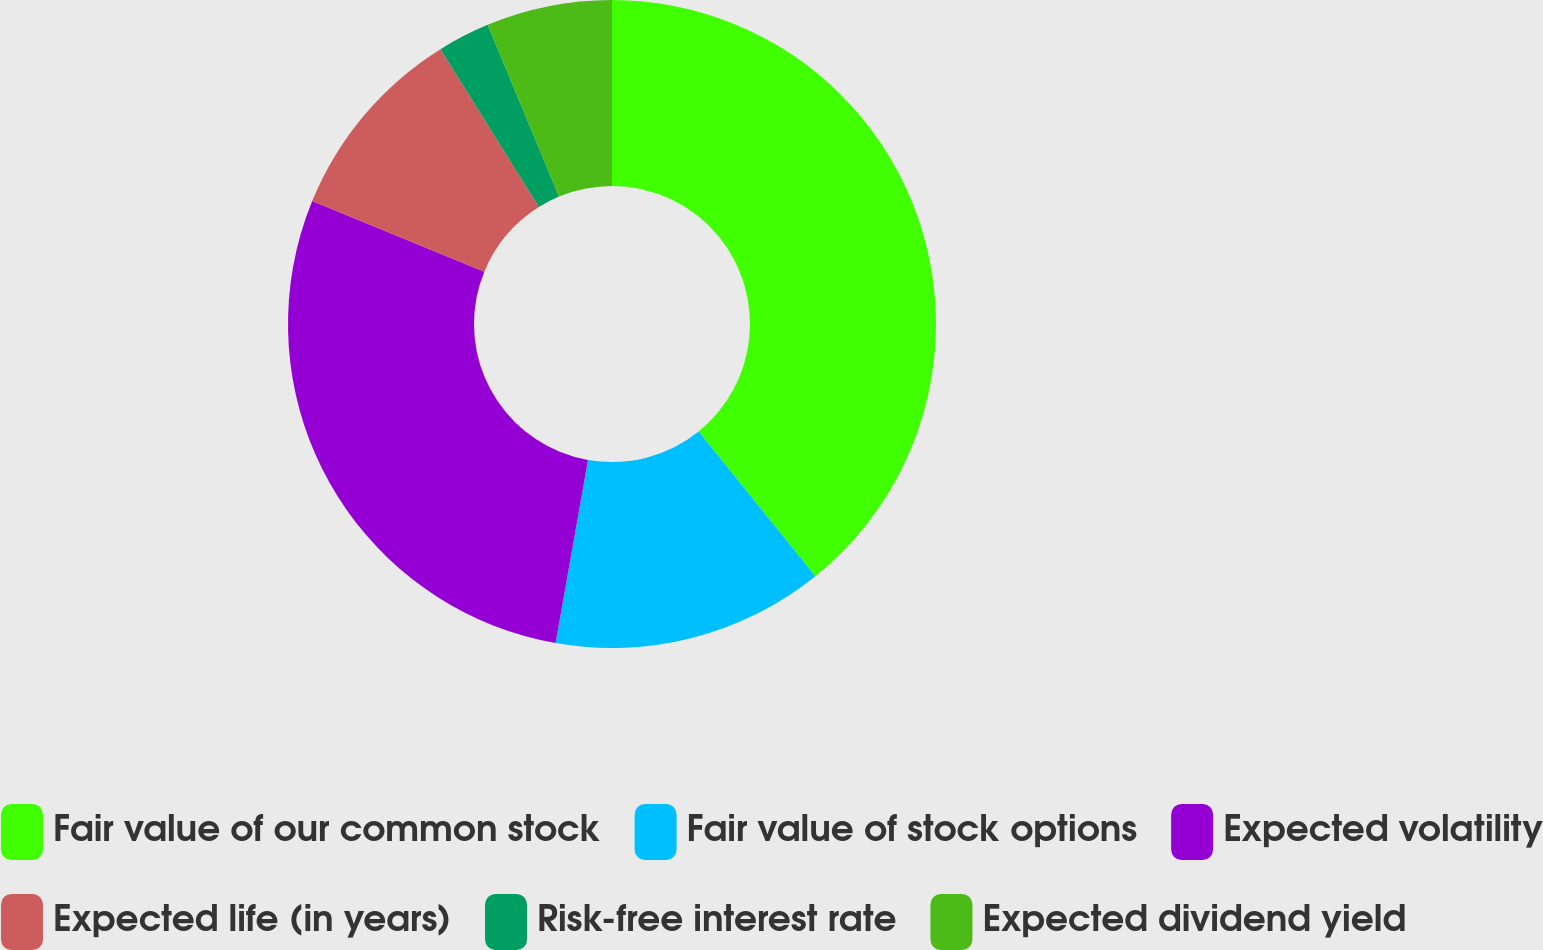Convert chart. <chart><loc_0><loc_0><loc_500><loc_500><pie_chart><fcel>Fair value of our common stock<fcel>Fair value of stock options<fcel>Expected volatility<fcel>Expected life (in years)<fcel>Risk-free interest rate<fcel>Expected dividend yield<nl><fcel>39.2%<fcel>13.59%<fcel>28.41%<fcel>9.93%<fcel>2.61%<fcel>6.27%<nl></chart> 